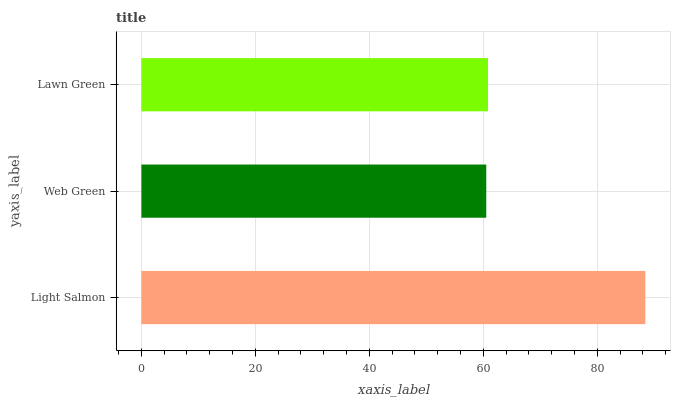Is Web Green the minimum?
Answer yes or no. Yes. Is Light Salmon the maximum?
Answer yes or no. Yes. Is Lawn Green the minimum?
Answer yes or no. No. Is Lawn Green the maximum?
Answer yes or no. No. Is Lawn Green greater than Web Green?
Answer yes or no. Yes. Is Web Green less than Lawn Green?
Answer yes or no. Yes. Is Web Green greater than Lawn Green?
Answer yes or no. No. Is Lawn Green less than Web Green?
Answer yes or no. No. Is Lawn Green the high median?
Answer yes or no. Yes. Is Lawn Green the low median?
Answer yes or no. Yes. Is Light Salmon the high median?
Answer yes or no. No. Is Web Green the low median?
Answer yes or no. No. 